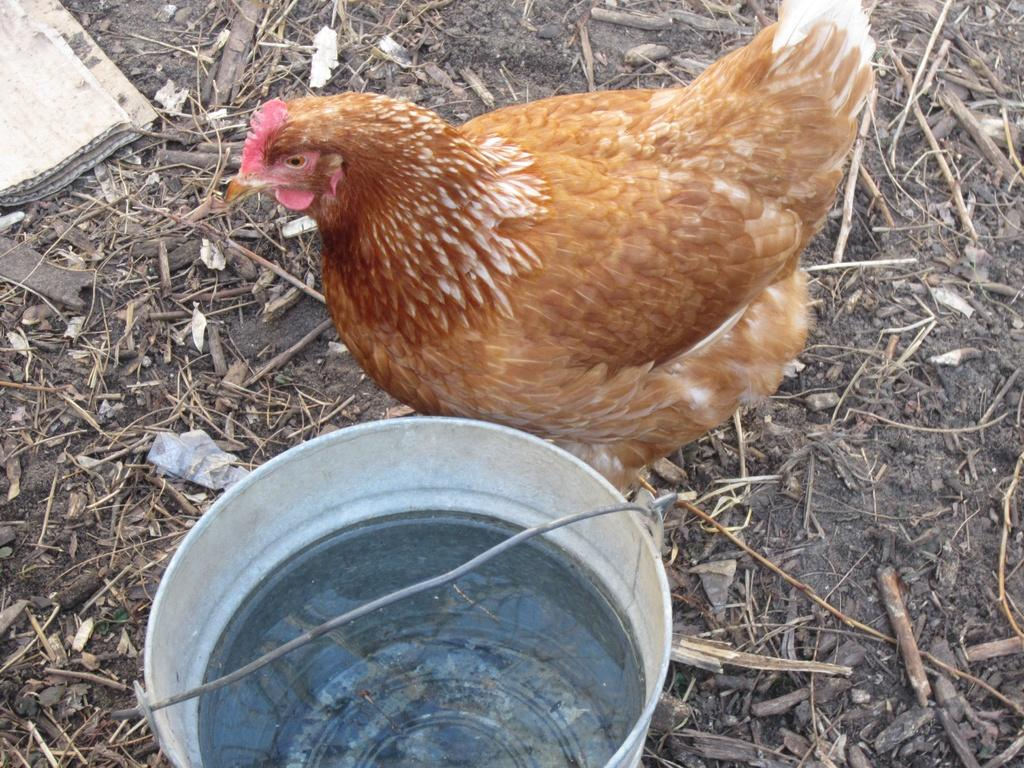What type of animal is present in the image? There is a hen in the image. Can you describe the color of the hen? The hen is brown in color. What object can be seen in the image that is typically used for holding liquids? There is a bucket in the image, and it contains water. What material is the object on the left side of the image made of? The object on the left side of the image is a cardboard sheet. Can you hear the horn of a vehicle in the image? There is no horn or vehicle present in the image, so it is not possible to hear any sounds related to them. 